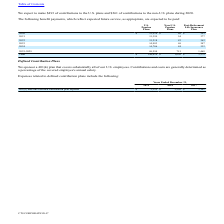According to Cts Corporation's financial document, How much does the company expect to pay for U.S. Pension Plans in 2021? According to the financial document, 15,399 (in thousands). The relevant text states: "2021 15,399 54 377..." Also, How much does the company expect to pay for Post-Retirement Life Insurance Plans in 2023? According to the financial document, 347 (in thousands). The relevant text states: "2023 14,983 69 347..." Also, How much does the company expect to contribute to the U.S. plans during 2020? According to the financial document, 493 (in thousands). The relevant text states: "We expect to make $493 of contributions to the U.S. plans and $261 of contributions to the non-U.S. plans during 2020...." Also, How many years were expected payments to Non-U.S. Pension Plans less than $50 thousand for 2020-2024?  Based on the analysis, there are 1 instances. The counting process: 2020. Also, can you calculate: What was the difference in the total expected payments between Non-U.S. Pension Plans and Post-Retirement Life Insurance Plan? Based on the calculation: 3,279-1,050, the result is 2229 (in thousands). This is based on the information: "Total $ 144,414 $ 1,050 $ 3,279 Total $ 144,414 $ 1,050 $ 3,279..." The key data points involved are: 1,050, 3,279. Also, can you calculate: What was the percentage change in the expected payments to U.S. Pension Plans between 2023 and 2024? To answer this question, I need to perform calculations using the financial data. The calculation is:  (14,706 - 14,983 )/ 14,983 , which equals -1.85 (percentage). This is based on the information: "2024 14,706 84 332 2023 14,983 69 347..." The key data points involved are: 14,706, 14,983. 